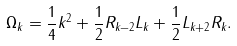<formula> <loc_0><loc_0><loc_500><loc_500>\Omega _ { k } = \frac { 1 } { 4 } k ^ { 2 } + \frac { 1 } { 2 } R _ { k - 2 } L _ { k } + \frac { 1 } { 2 } L _ { k + 2 } R _ { k } .</formula> 